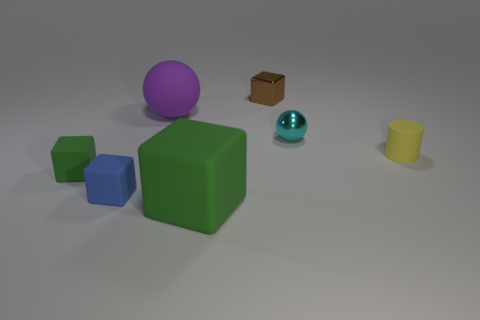There is a shiny object right of the small brown metal block; is it the same shape as the purple thing?
Your answer should be compact. Yes. How many cubes are large purple things or tiny yellow matte objects?
Provide a short and direct response. 0. How many small green matte objects are there?
Ensure brevity in your answer.  1. There is a matte thing behind the cylinder on the right side of the tiny brown object; what is its size?
Your answer should be compact. Large. How many other objects are the same size as the cylinder?
Your response must be concise. 4. There is a rubber sphere; how many tiny shiny things are behind it?
Offer a terse response. 1. What is the size of the yellow rubber cylinder?
Provide a short and direct response. Small. Do the block that is behind the matte ball and the ball that is on the right side of the shiny cube have the same material?
Your answer should be very brief. Yes. Are there any small things that have the same color as the large rubber block?
Provide a short and direct response. Yes. The rubber cylinder that is the same size as the brown cube is what color?
Provide a short and direct response. Yellow. 